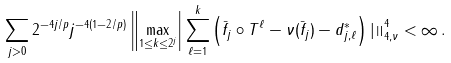<formula> <loc_0><loc_0><loc_500><loc_500>\sum _ { j > 0 } 2 ^ { - 4 j / p } j ^ { - 4 ( 1 - 2 / p ) } \left \| \max _ { 1 \leq k \leq 2 ^ { j } } \right | \sum _ { \ell = 1 } ^ { k } \left ( \bar { f } _ { j } \circ T ^ { \ell } - \nu ( \bar { f } _ { j } ) - d ^ { * } _ { j , \ell } \right ) \left | \right \| ^ { 4 } _ { 4 , \nu } < \infty \, .</formula> 